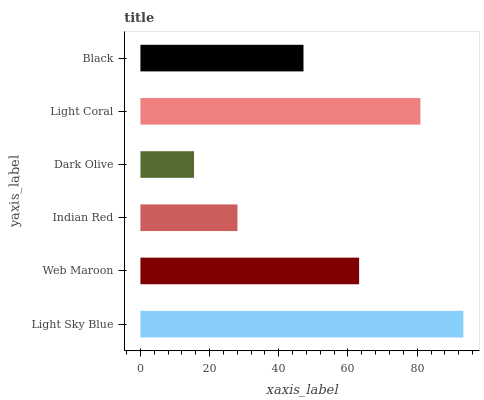Is Dark Olive the minimum?
Answer yes or no. Yes. Is Light Sky Blue the maximum?
Answer yes or no. Yes. Is Web Maroon the minimum?
Answer yes or no. No. Is Web Maroon the maximum?
Answer yes or no. No. Is Light Sky Blue greater than Web Maroon?
Answer yes or no. Yes. Is Web Maroon less than Light Sky Blue?
Answer yes or no. Yes. Is Web Maroon greater than Light Sky Blue?
Answer yes or no. No. Is Light Sky Blue less than Web Maroon?
Answer yes or no. No. Is Web Maroon the high median?
Answer yes or no. Yes. Is Black the low median?
Answer yes or no. Yes. Is Light Sky Blue the high median?
Answer yes or no. No. Is Light Coral the low median?
Answer yes or no. No. 